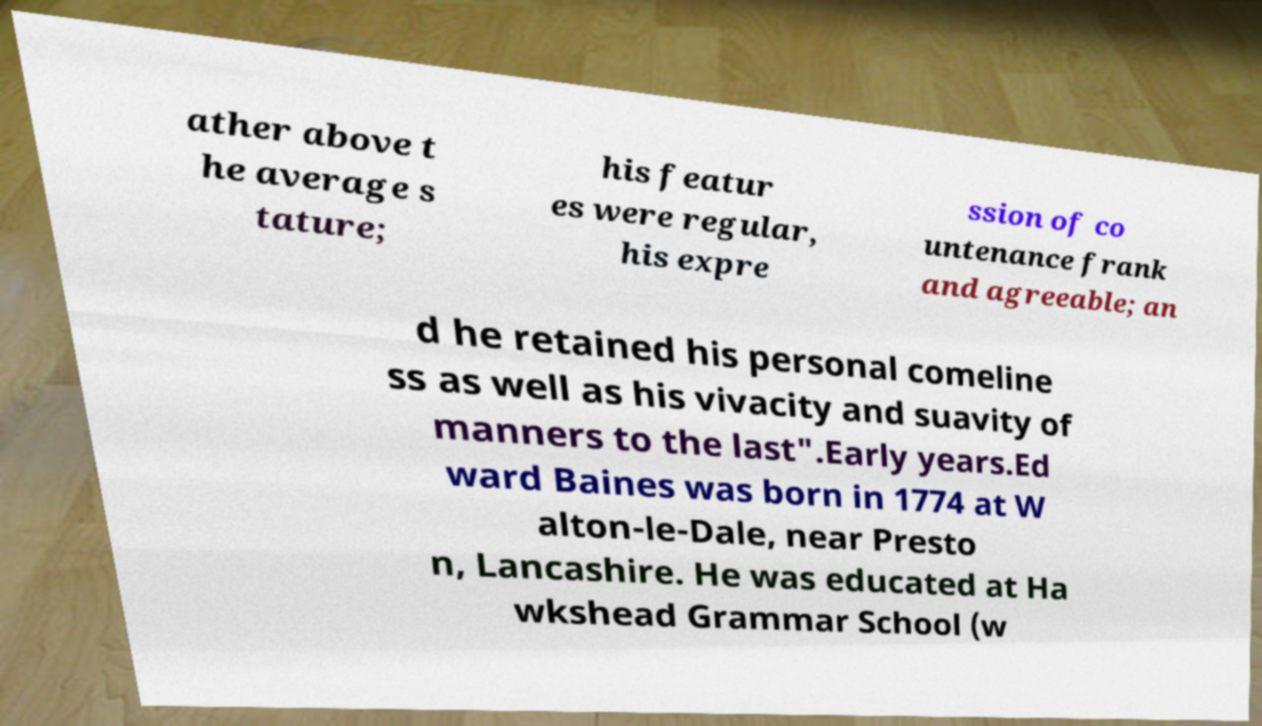Can you read and provide the text displayed in the image?This photo seems to have some interesting text. Can you extract and type it out for me? ather above t he average s tature; his featur es were regular, his expre ssion of co untenance frank and agreeable; an d he retained his personal comeline ss as well as his vivacity and suavity of manners to the last".Early years.Ed ward Baines was born in 1774 at W alton-le-Dale, near Presto n, Lancashire. He was educated at Ha wkshead Grammar School (w 